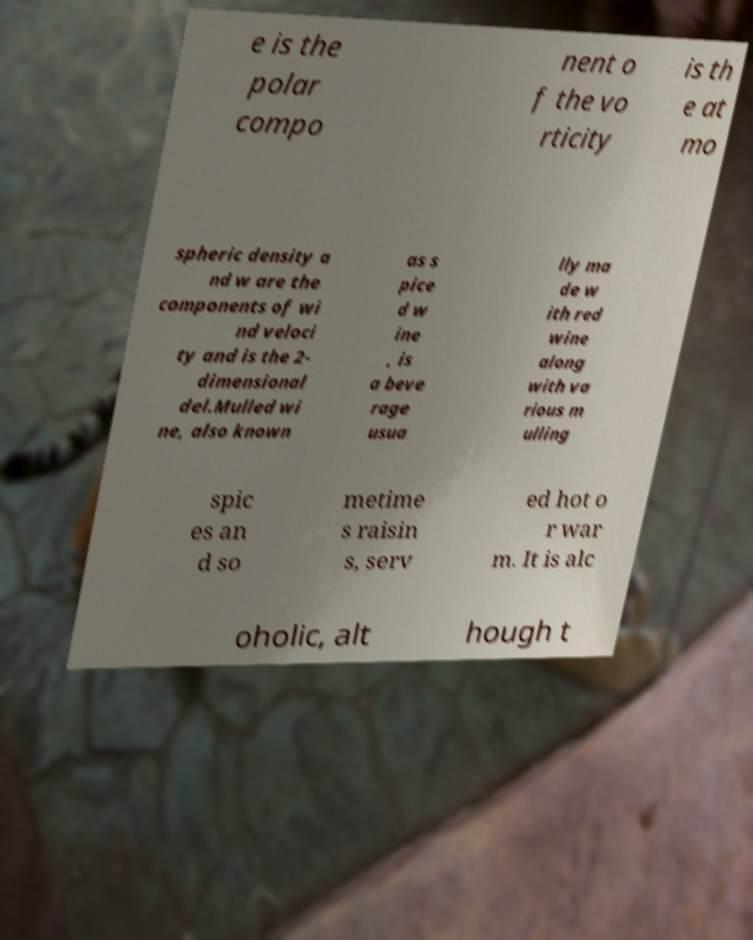Can you read and provide the text displayed in the image?This photo seems to have some interesting text. Can you extract and type it out for me? e is the polar compo nent o f the vo rticity is th e at mo spheric density a nd w are the components of wi nd veloci ty and is the 2- dimensional del.Mulled wi ne, also known as s pice d w ine , is a beve rage usua lly ma de w ith red wine along with va rious m ulling spic es an d so metime s raisin s, serv ed hot o r war m. It is alc oholic, alt hough t 